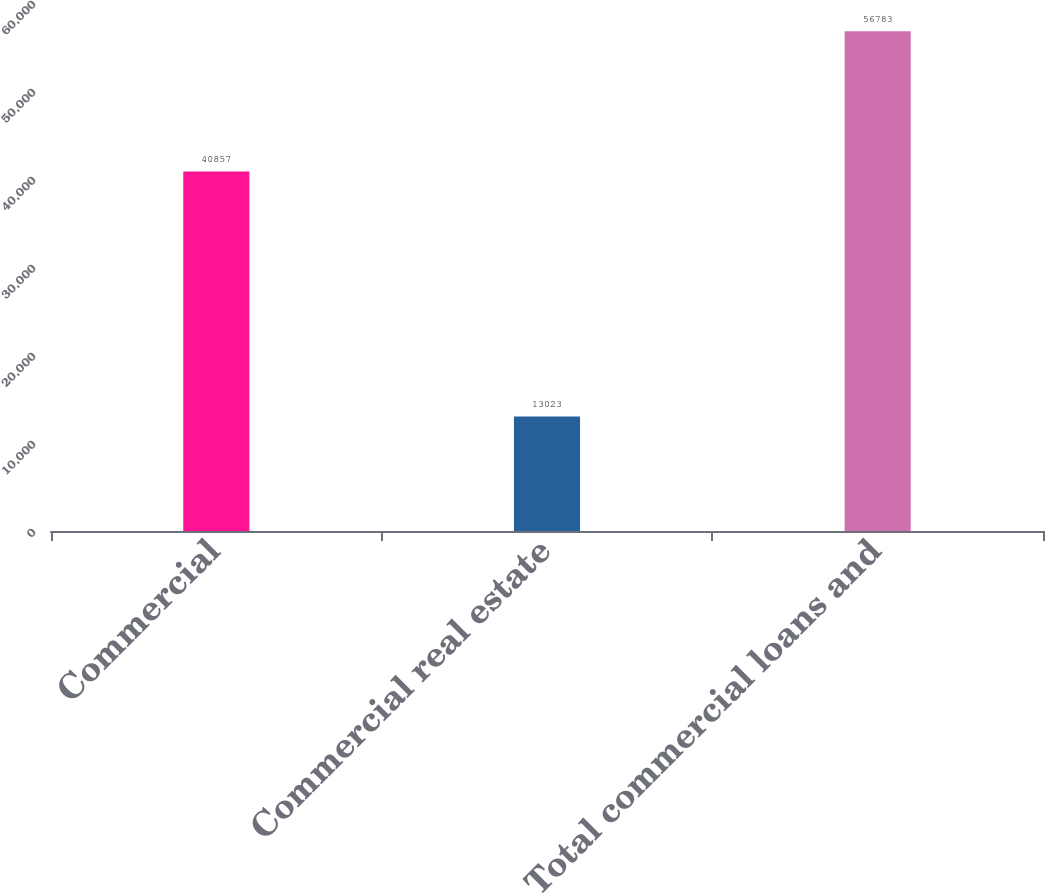<chart> <loc_0><loc_0><loc_500><loc_500><bar_chart><fcel>Commercial<fcel>Commercial real estate<fcel>Total commercial loans and<nl><fcel>40857<fcel>13023<fcel>56783<nl></chart> 